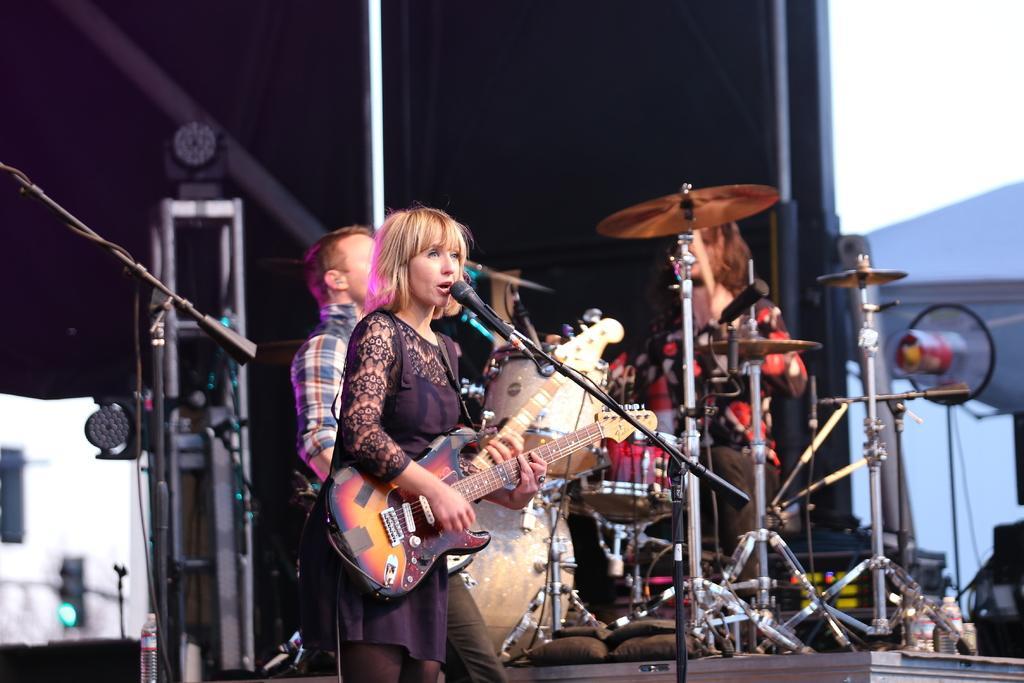Could you give a brief overview of what you see in this image? In this image we can see a woman standing on the stage. She is playing a guitar and she is singing on a microphone. Here we can see a man sitting on a chair and he is playing the snare drum. Here we can see a man. In the background, we can see the black cloth. 